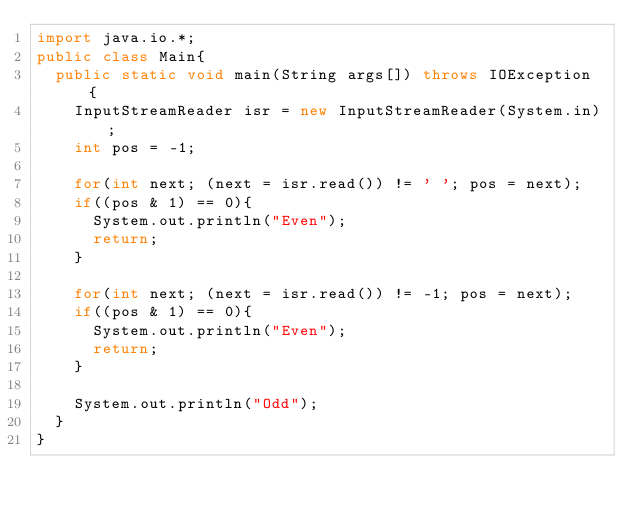Convert code to text. <code><loc_0><loc_0><loc_500><loc_500><_Java_>import java.io.*;
public class Main{
  public static void main(String args[]) throws IOException {
    InputStreamReader isr = new InputStreamReader(System.in);
    int pos = -1;
    
    for(int next; (next = isr.read()) != ' '; pos = next);
    if((pos & 1) == 0){
      System.out.println("Even");
      return;
    }
    
    for(int next; (next = isr.read()) != -1; pos = next);
    if((pos & 1) == 0){
      System.out.println("Even");
      return;
    }
    
    System.out.println("Odd");
  }
}</code> 